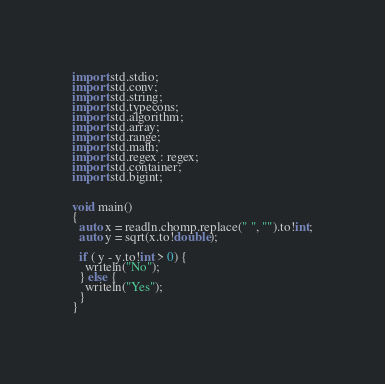Convert code to text. <code><loc_0><loc_0><loc_500><loc_500><_D_>import std.stdio;
import std.conv;
import std.string;
import std.typecons;
import std.algorithm;
import std.array;
import std.range;
import std.math;
import std.regex : regex;
import std.container;
import std.bigint;


void main()
{
  auto x = readln.chomp.replace(" ", "").to!int;
  auto y = sqrt(x.to!double);
  
  if ( y - y.to!int > 0) {
    writeln("No");
  } else {
    writeln("Yes");
  }
}
</code> 